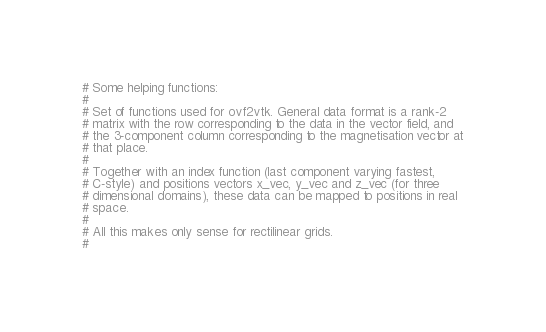Convert code to text. <code><loc_0><loc_0><loc_500><loc_500><_Python_>

# Some helping functions:
#
# Set of functions used for ovf2vtk. General data format is a rank-2
# matrix with the row corresponding to the data in the vector field, and
# the 3-component column corresponding to the magnetisation vector at
# that place.
#
# Together with an index function (last component varying fastest,
# C-style) and positions vectors x_vec, y_vec and z_vec (for three
# dimensional domains), these data can be mapped to positions in real
# space.
#
# All this makes only sense for rectilinear grids.
#</code> 